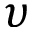<formula> <loc_0><loc_0><loc_500><loc_500>\upsilon</formula> 